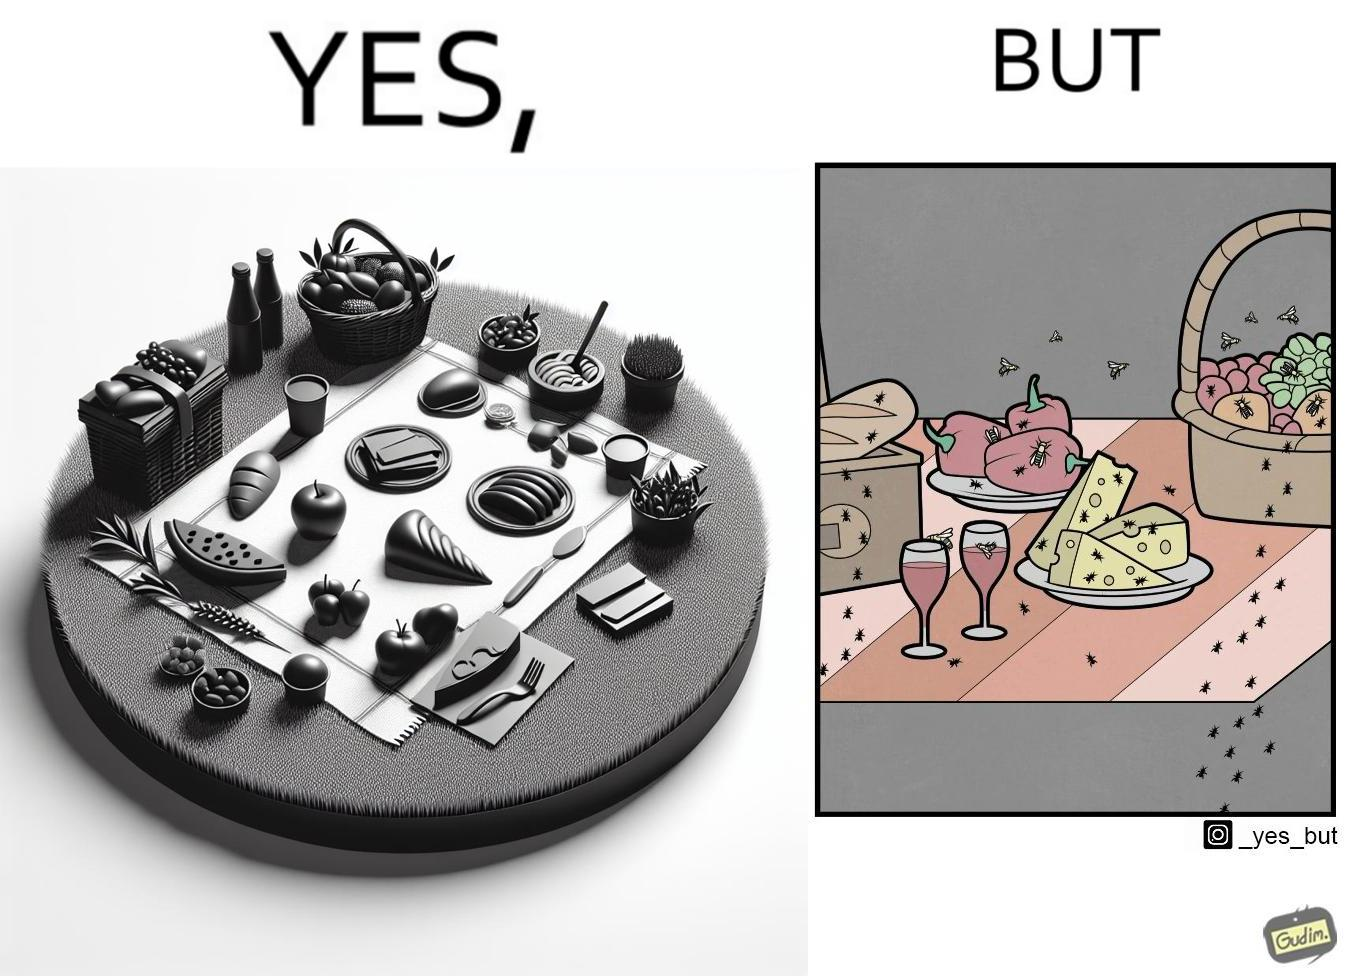Describe the content of this image. The Picture shows that although we enjoy food in garden but there are some consequences of eating food in garden. Many bugs and bees are attracted towards our food and make our food sometimes non-eatable. 